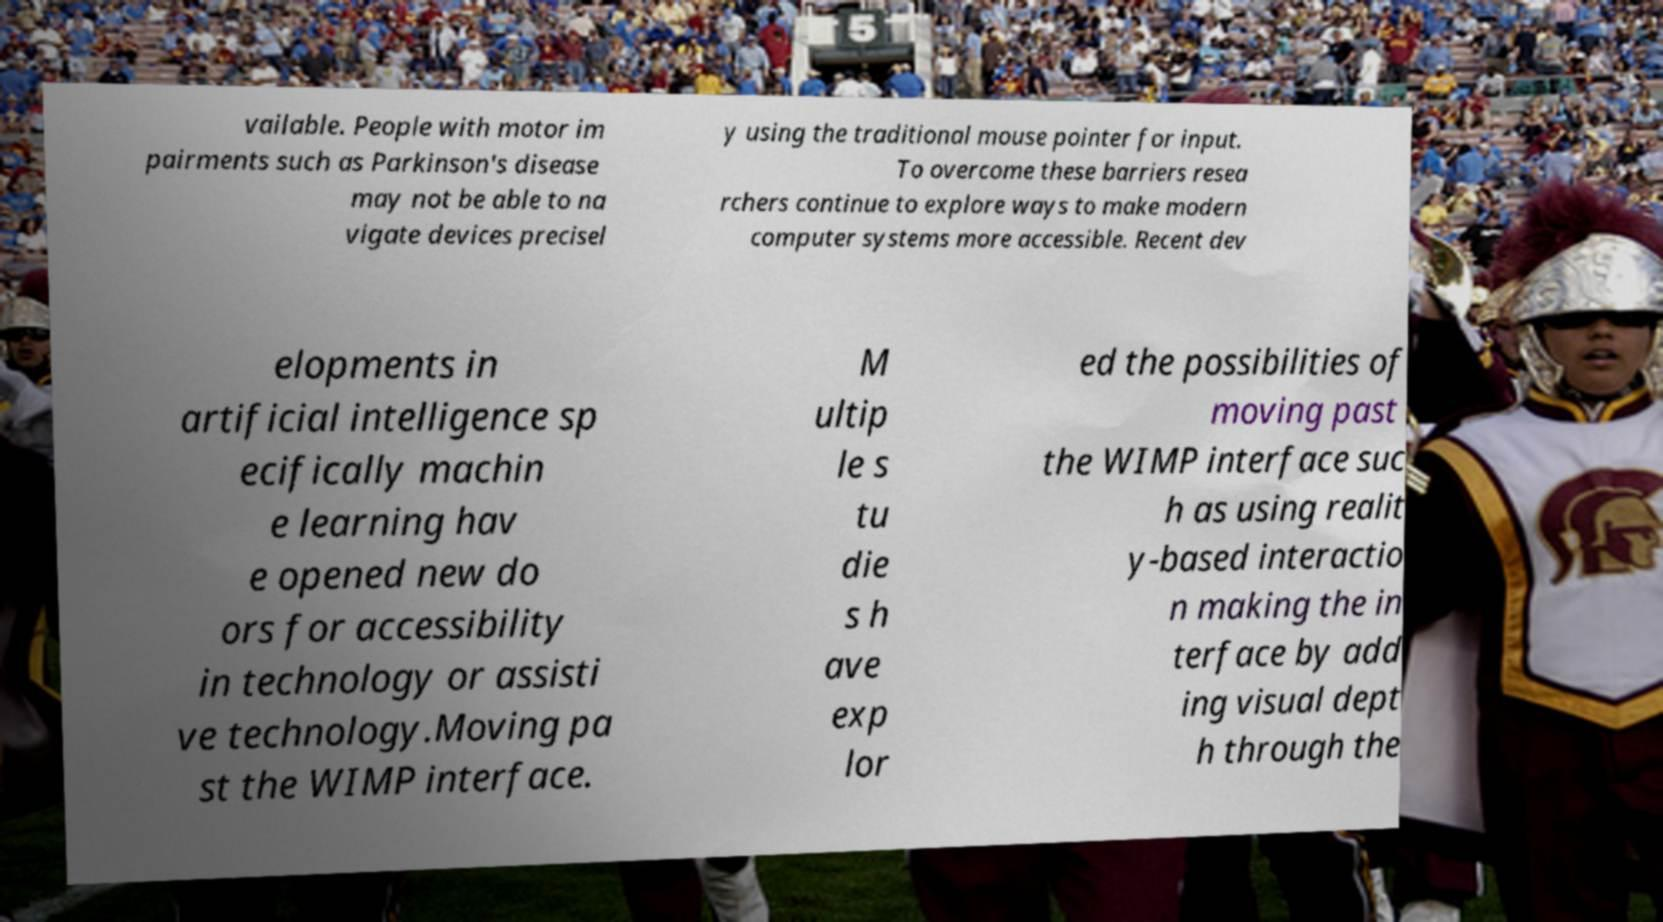For documentation purposes, I need the text within this image transcribed. Could you provide that? vailable. People with motor im pairments such as Parkinson's disease may not be able to na vigate devices precisel y using the traditional mouse pointer for input. To overcome these barriers resea rchers continue to explore ways to make modern computer systems more accessible. Recent dev elopments in artificial intelligence sp ecifically machin e learning hav e opened new do ors for accessibility in technology or assisti ve technology.Moving pa st the WIMP interface. M ultip le s tu die s h ave exp lor ed the possibilities of moving past the WIMP interface suc h as using realit y-based interactio n making the in terface by add ing visual dept h through the 